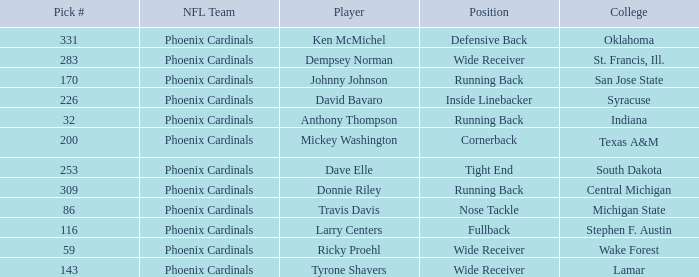Which college has a nose tackle position? Michigan State. 